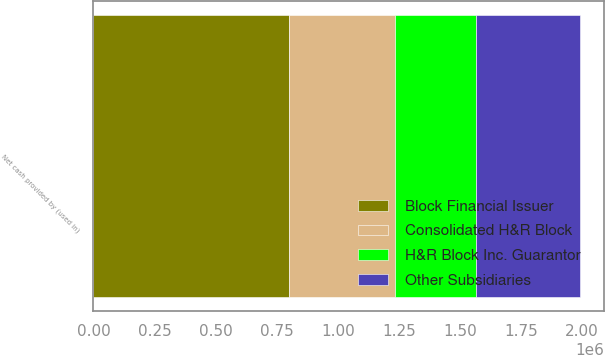<chart> <loc_0><loc_0><loc_500><loc_500><stacked_bar_chart><ecel><fcel>Net cash provided by (used in)<nl><fcel>Consolidated H&R Block<fcel>436843<nl><fcel>H&R Block Inc. Guarantor<fcel>332328<nl><fcel>Block Financial Issuer<fcel>798305<nl><fcel>Other Subsidiaries<fcel>421702<nl></chart> 